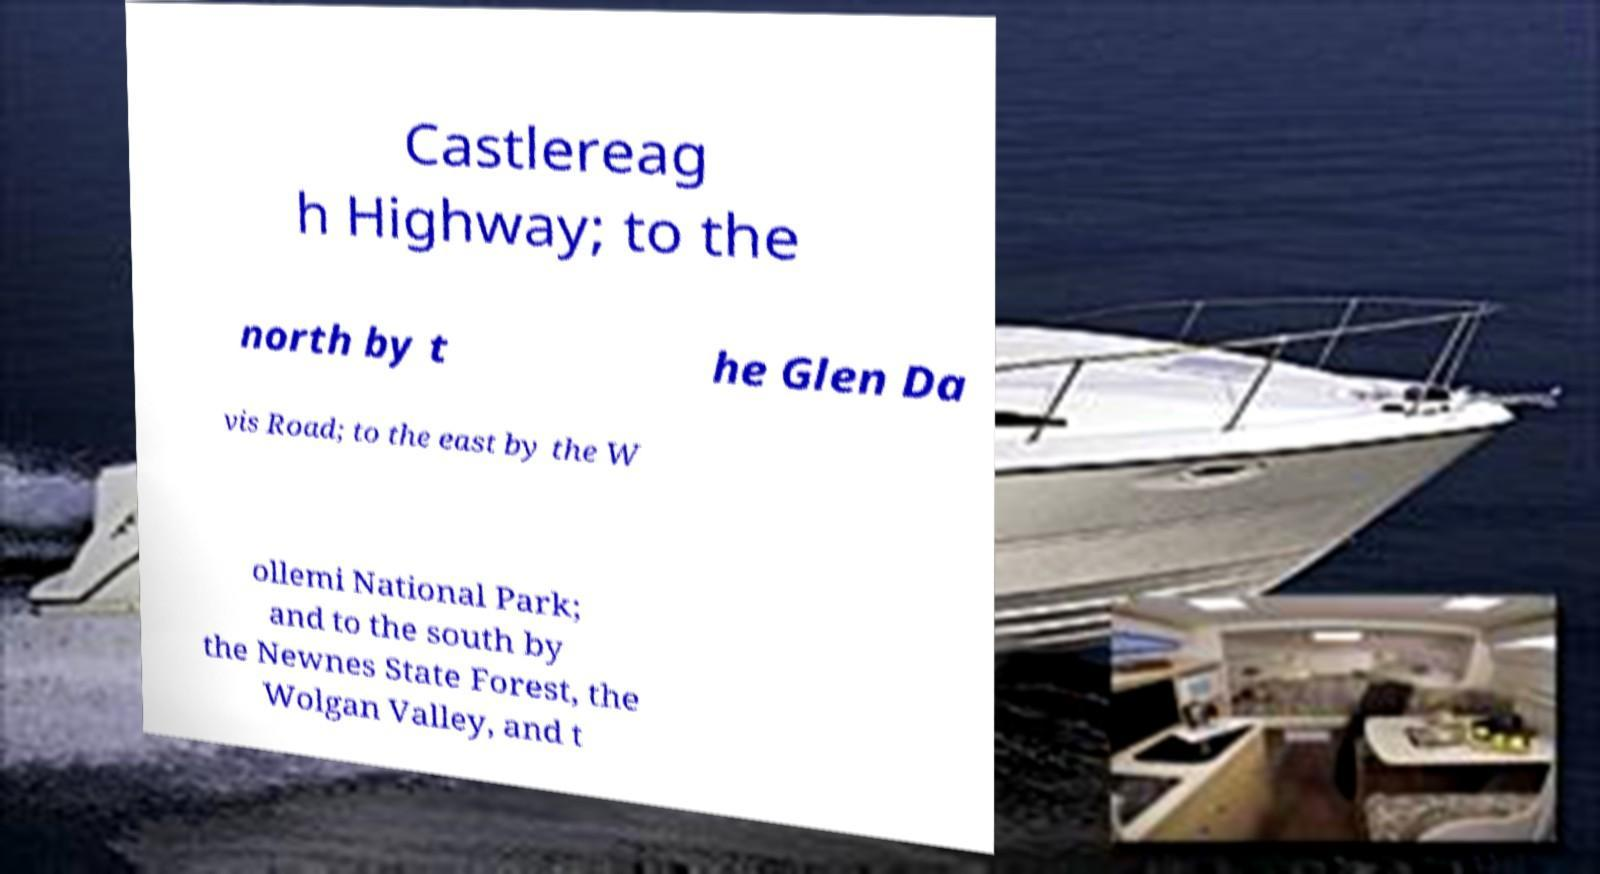For documentation purposes, I need the text within this image transcribed. Could you provide that? Castlereag h Highway; to the north by t he Glen Da vis Road; to the east by the W ollemi National Park; and to the south by the Newnes State Forest, the Wolgan Valley, and t 